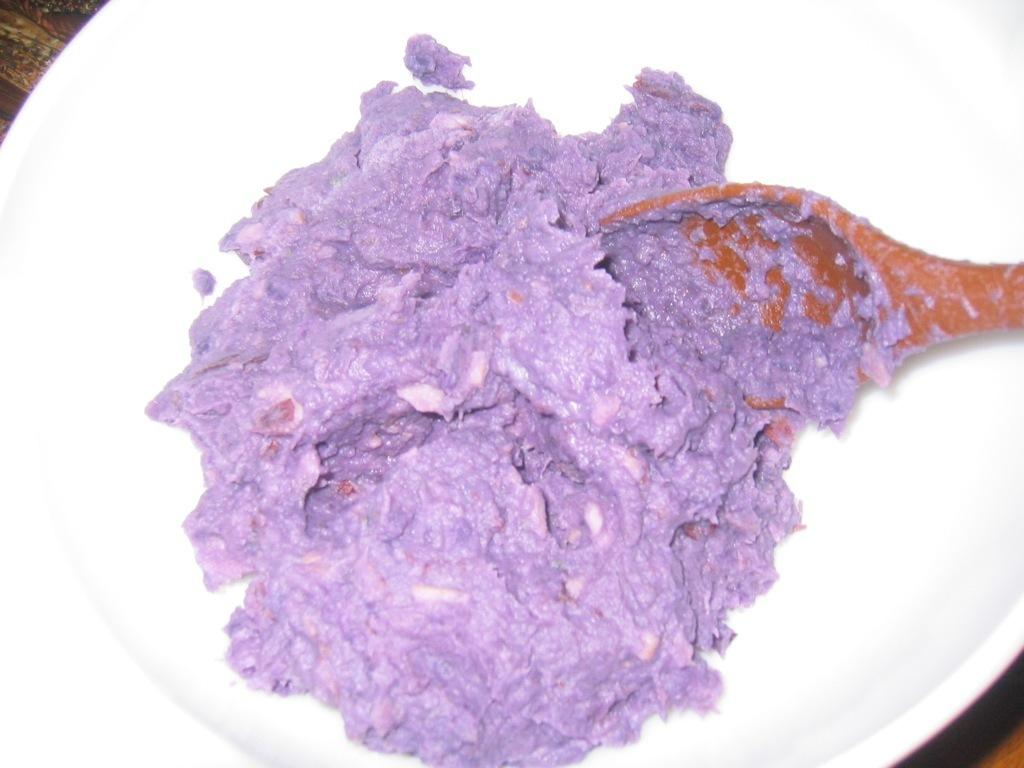What is the main object in the center of the image? There is a plate in the center of the image. What is on the plate? The plate contains taiyaki. What utensil is present on the plate? There is a spoon in the plate. Can you see any wrens sitting on the taiyaki in the image? There are no wrens present in the image. What type of cakes are being served alongside the taiyaki in the image? There is no mention of cakes in the image; it only features a plate with taiyaki and a spoon. 